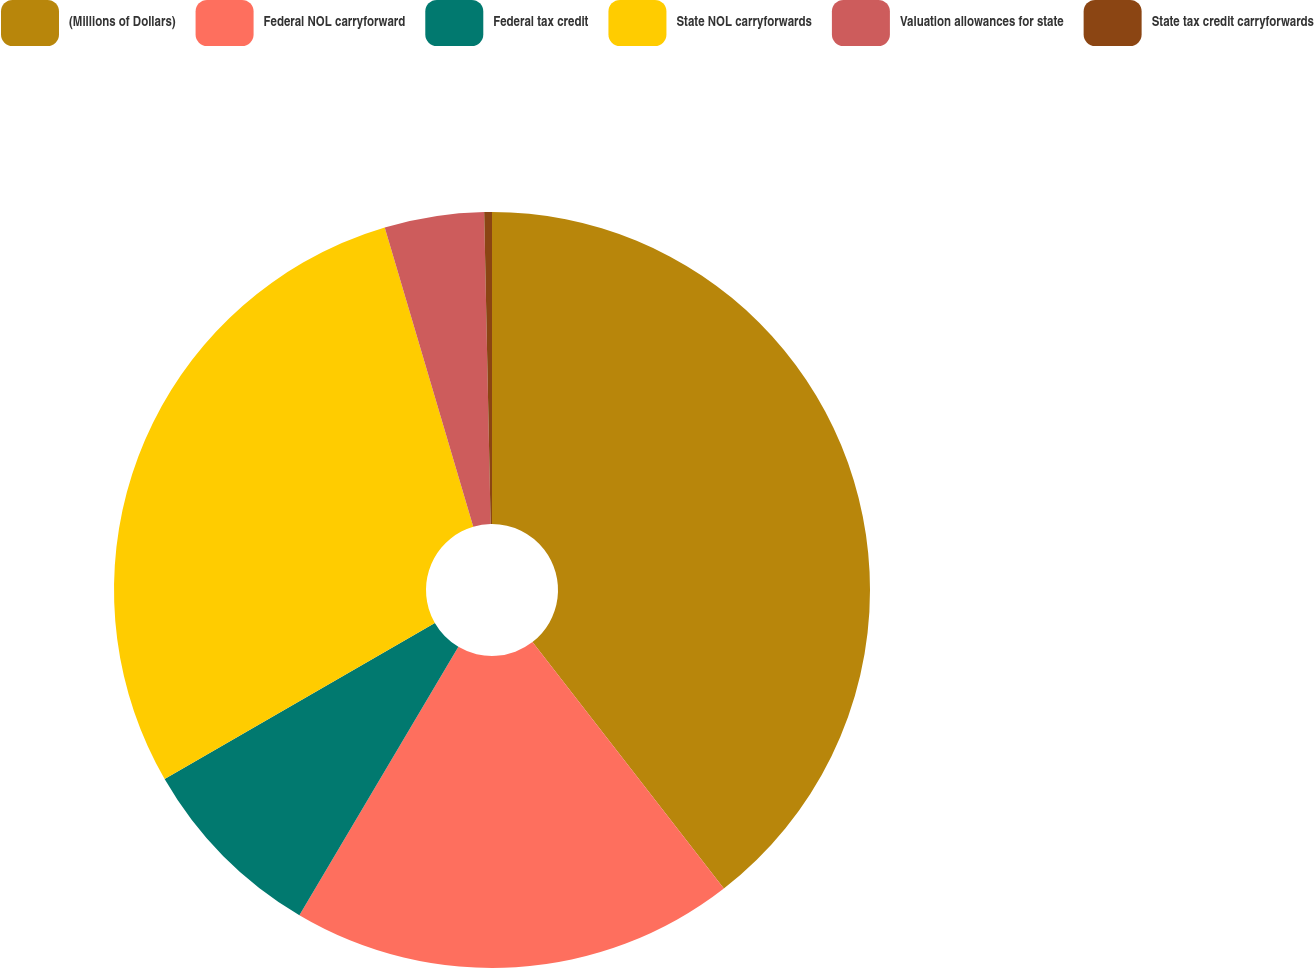<chart> <loc_0><loc_0><loc_500><loc_500><pie_chart><fcel>(Millions of Dollars)<fcel>Federal NOL carryforward<fcel>Federal tax credit<fcel>State NOL carryforwards<fcel>Valuation allowances for state<fcel>State tax credit carryforwards<nl><fcel>39.49%<fcel>19.02%<fcel>8.16%<fcel>28.75%<fcel>4.25%<fcel>0.33%<nl></chart> 